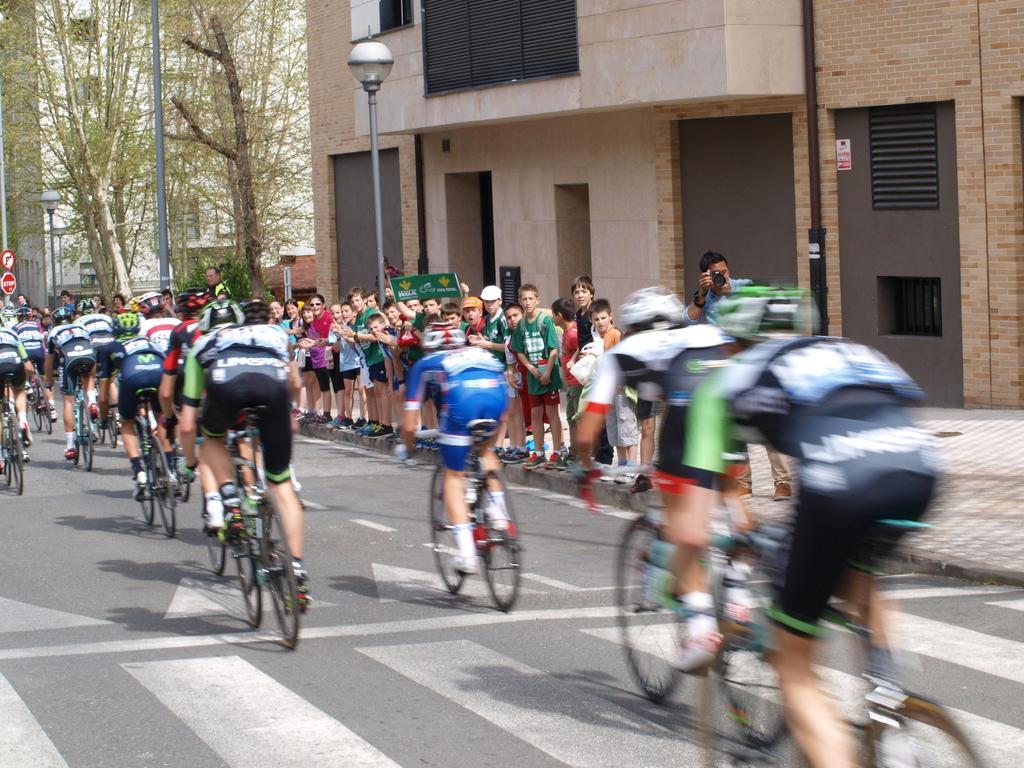Could you give a brief overview of what you see in this image? In the image we can see there are people who are sitting on bicycles and others are standing on footpath and there are lot of trees. 